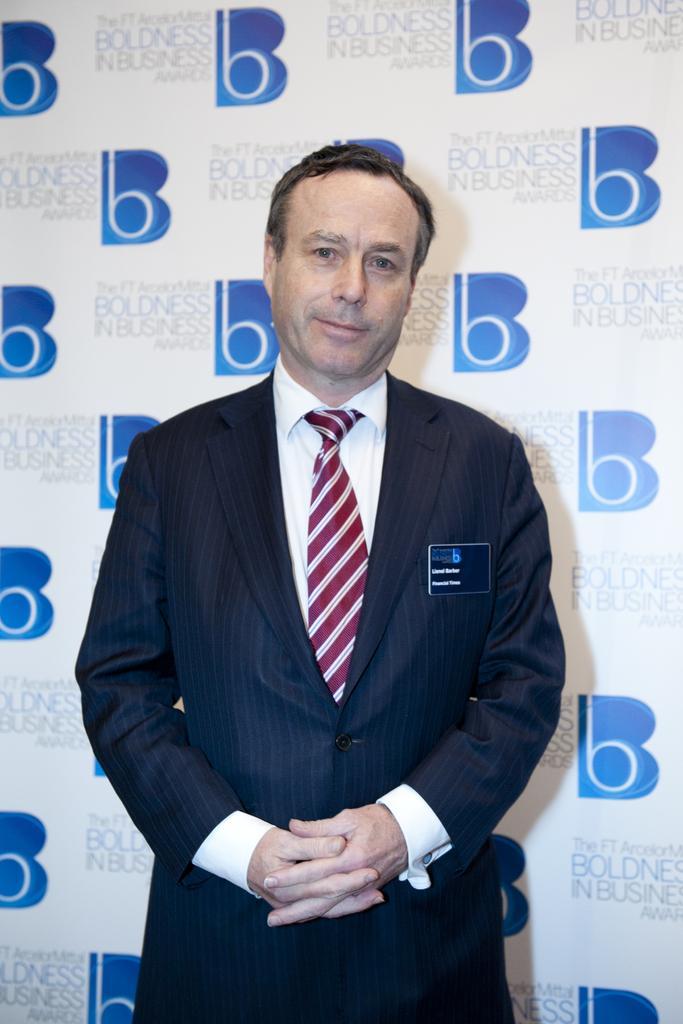Please provide a concise description of this image. In the image there is a man standing. And there is a card on his jacket. Behind him there is a banner with text on it. 